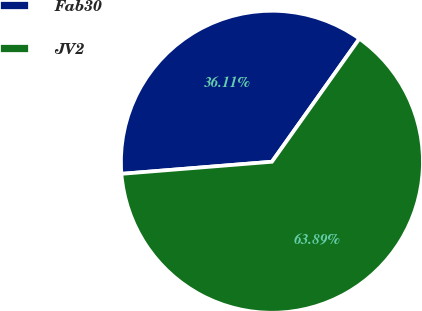Convert chart to OTSL. <chart><loc_0><loc_0><loc_500><loc_500><pie_chart><fcel>Fab30<fcel>JV2<nl><fcel>36.11%<fcel>63.89%<nl></chart> 